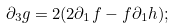Convert formula to latex. <formula><loc_0><loc_0><loc_500><loc_500>\partial _ { 3 } g = 2 ( 2 \partial _ { 1 } f - f \partial _ { 1 } h ) ;</formula> 